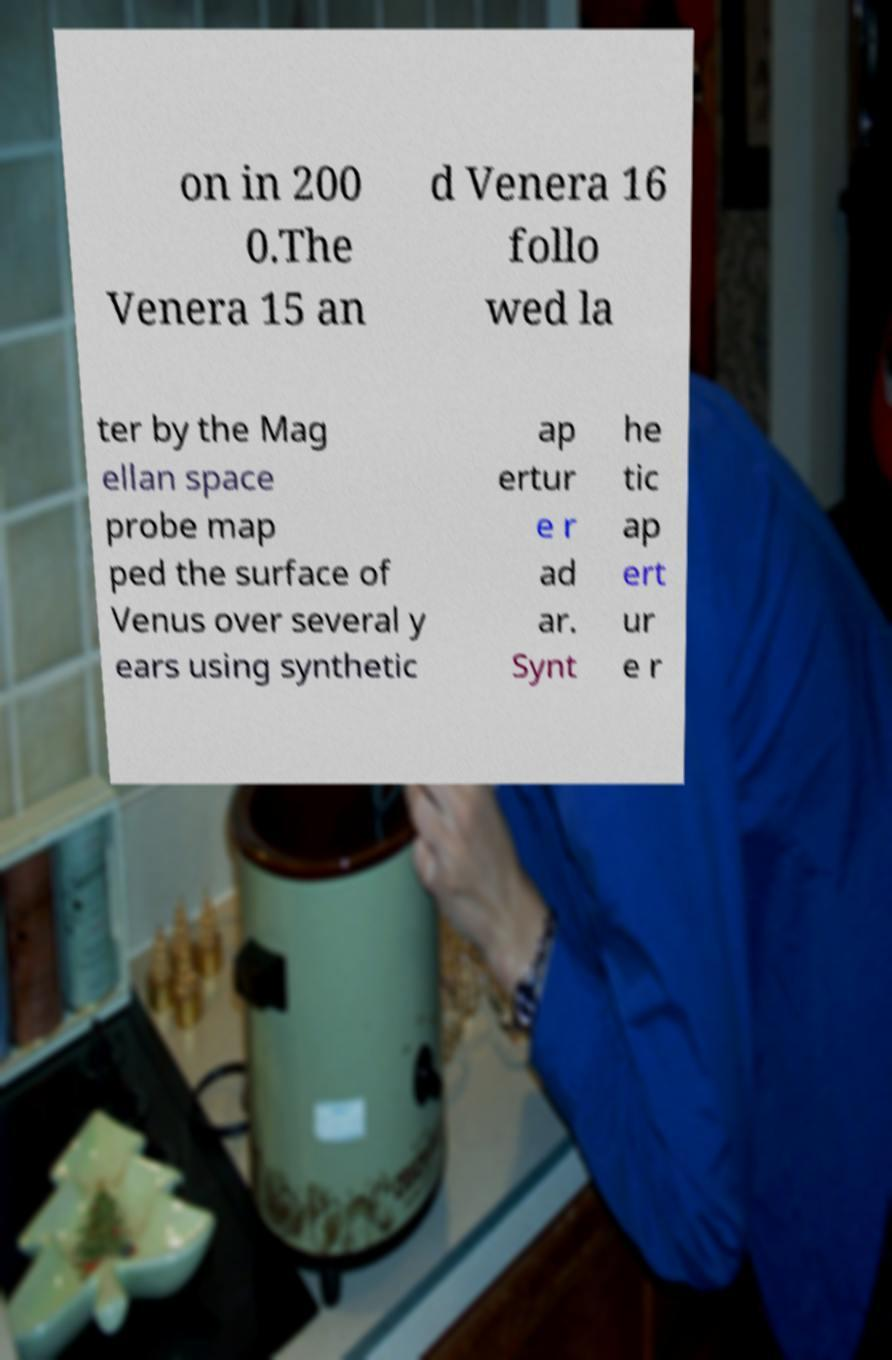Please identify and transcribe the text found in this image. on in 200 0.The Venera 15 an d Venera 16 follo wed la ter by the Mag ellan space probe map ped the surface of Venus over several y ears using synthetic ap ertur e r ad ar. Synt he tic ap ert ur e r 